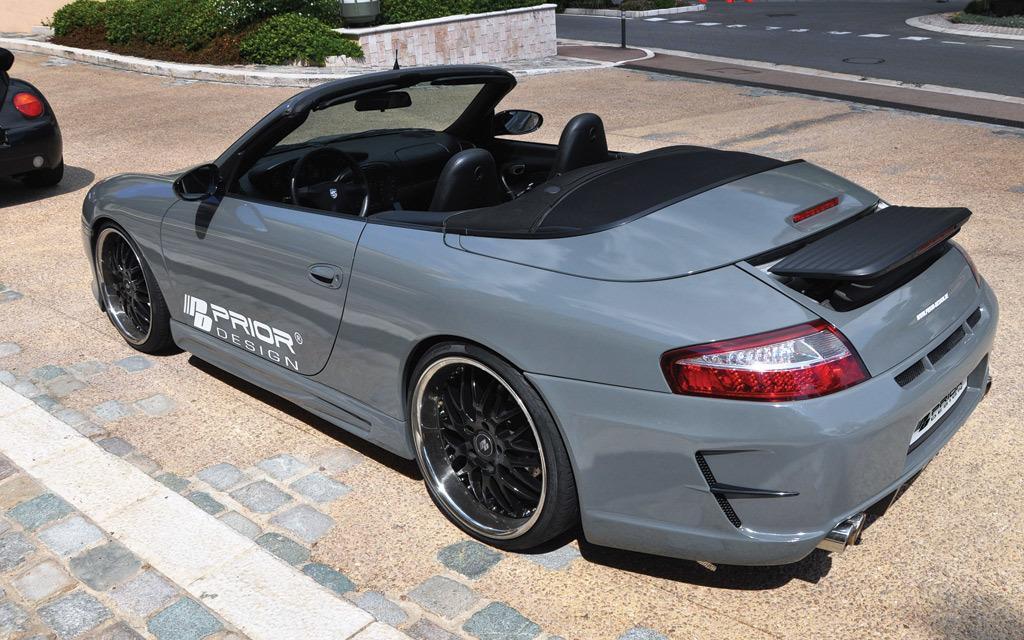Could you give a brief overview of what you see in this image? In this image i can see a grey colored car in which there are black seats, and i can see it has black tires. In the background i can see the road, few plants, another vehicle and the side walk. 